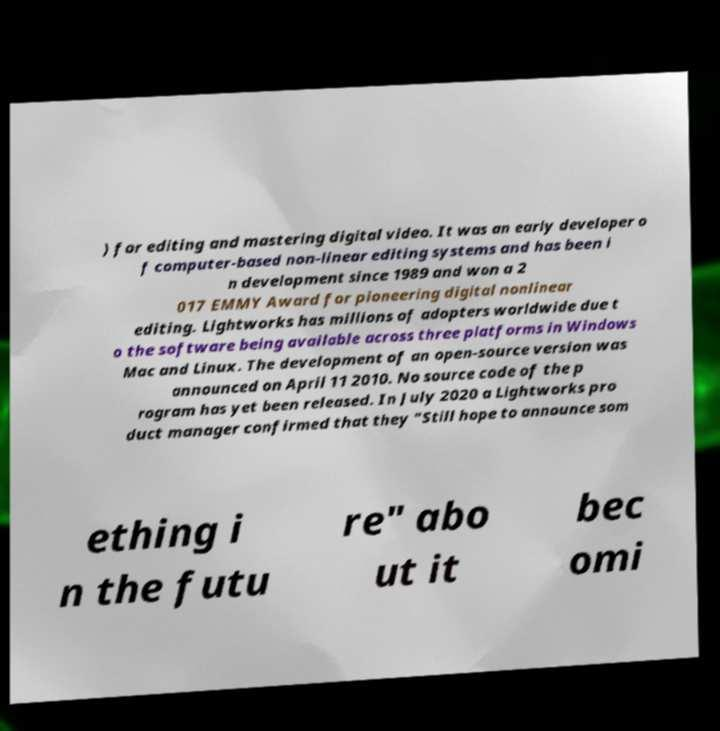Can you accurately transcribe the text from the provided image for me? ) for editing and mastering digital video. It was an early developer o f computer-based non-linear editing systems and has been i n development since 1989 and won a 2 017 EMMY Award for pioneering digital nonlinear editing. Lightworks has millions of adopters worldwide due t o the software being available across three platforms in Windows Mac and Linux. The development of an open-source version was announced on April 11 2010. No source code of the p rogram has yet been released. In July 2020 a Lightworks pro duct manager confirmed that they "Still hope to announce som ething i n the futu re" abo ut it bec omi 